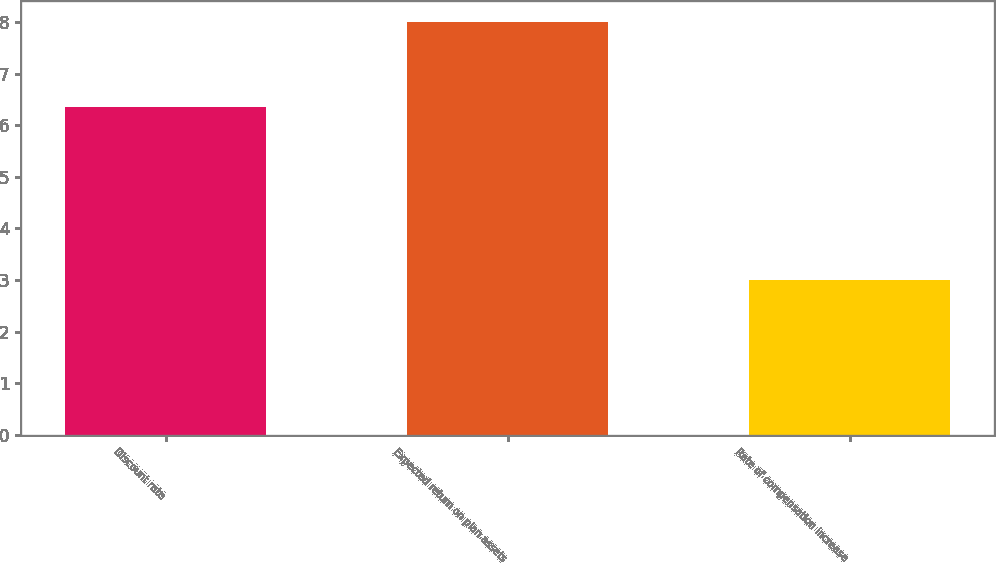Convert chart. <chart><loc_0><loc_0><loc_500><loc_500><bar_chart><fcel>Discount rate<fcel>Expected return on plan assets<fcel>Rate of compensation increase<nl><fcel>6.35<fcel>8<fcel>3<nl></chart> 